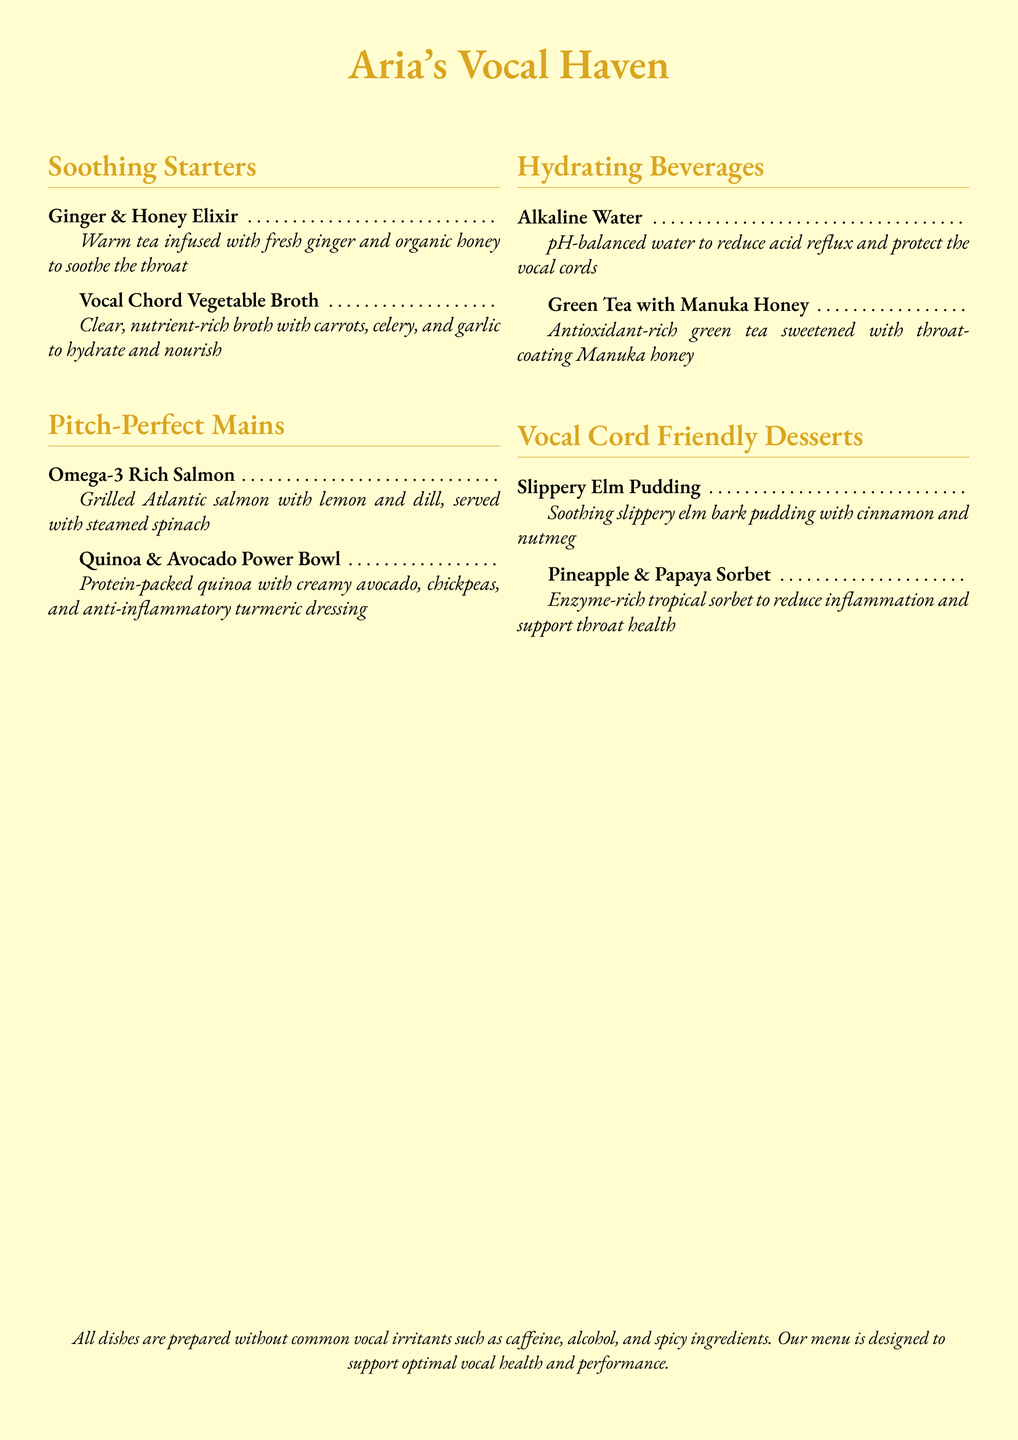What is the name of the restaurant? The restaurant is titled "Aria's Vocal Haven."
Answer: Aria's Vocal Haven What type of beverage is Ginger & Honey Elixir? It is a warm tea infused with fresh ginger and organic honey.
Answer: Warm tea What is served with the grilled Atlantic salmon? It is served with steamed spinach.
Answer: Steamed spinach What is included in the Quinoa & Avocado Power Bowl? The bowl includes quinoa, avocado, chickpeas, and turmeric dressing.
Answer: Quinoa, avocado, chickpeas, turmeric dressing Which dessert contains slippery elm bark? The dessert is called Slippery Elm Pudding.
Answer: Slippery Elm Pudding What is the main benefit of drinking Alkaline Water? It reduces acid reflux and protects the vocal cords.
Answer: Reduces acid reflux How is the Pineapple & Papaya Sorbet beneficial for throat health? It helps reduce inflammation and support throat health.
Answer: Reduces inflammation What kind of items are not prepared in the dishes? Common vocal irritants such as caffeine, alcohol, and spicy ingredients.
Answer: Caffeine, alcohol, spicy ingredients What is the color of the menu's background? The background color is cream.
Answer: Cream 